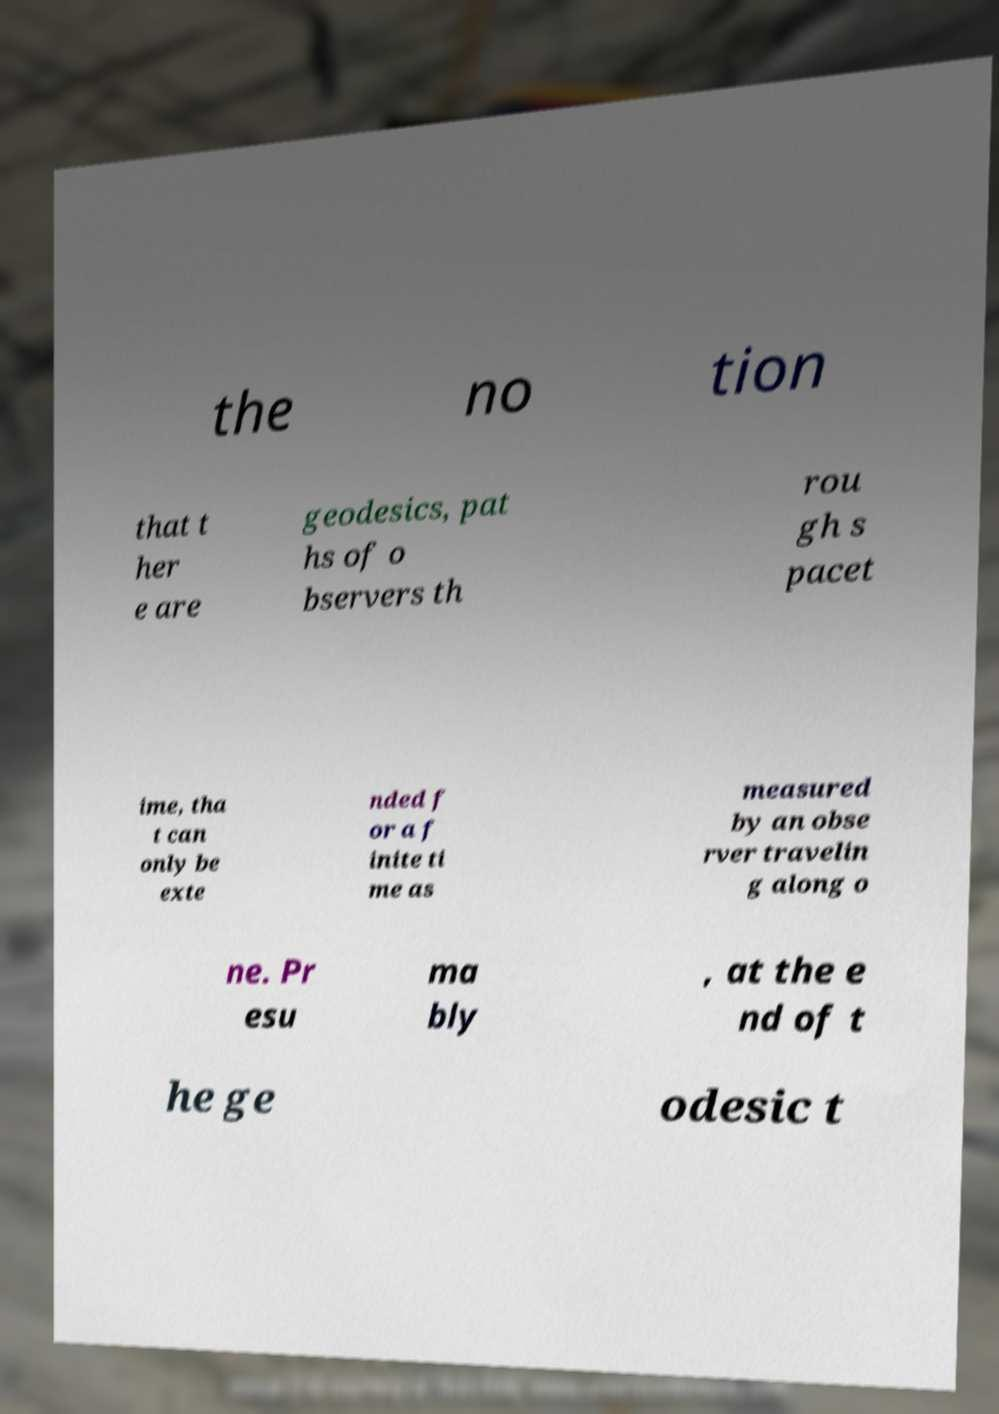For documentation purposes, I need the text within this image transcribed. Could you provide that? the no tion that t her e are geodesics, pat hs of o bservers th rou gh s pacet ime, tha t can only be exte nded f or a f inite ti me as measured by an obse rver travelin g along o ne. Pr esu ma bly , at the e nd of t he ge odesic t 